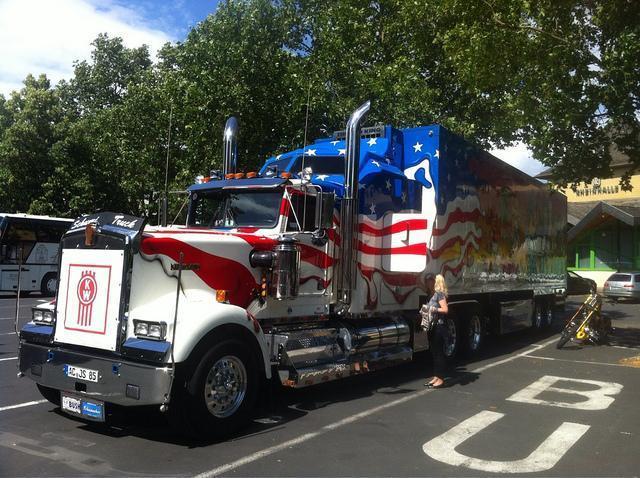How many trucks can you see?
Give a very brief answer. 1. 